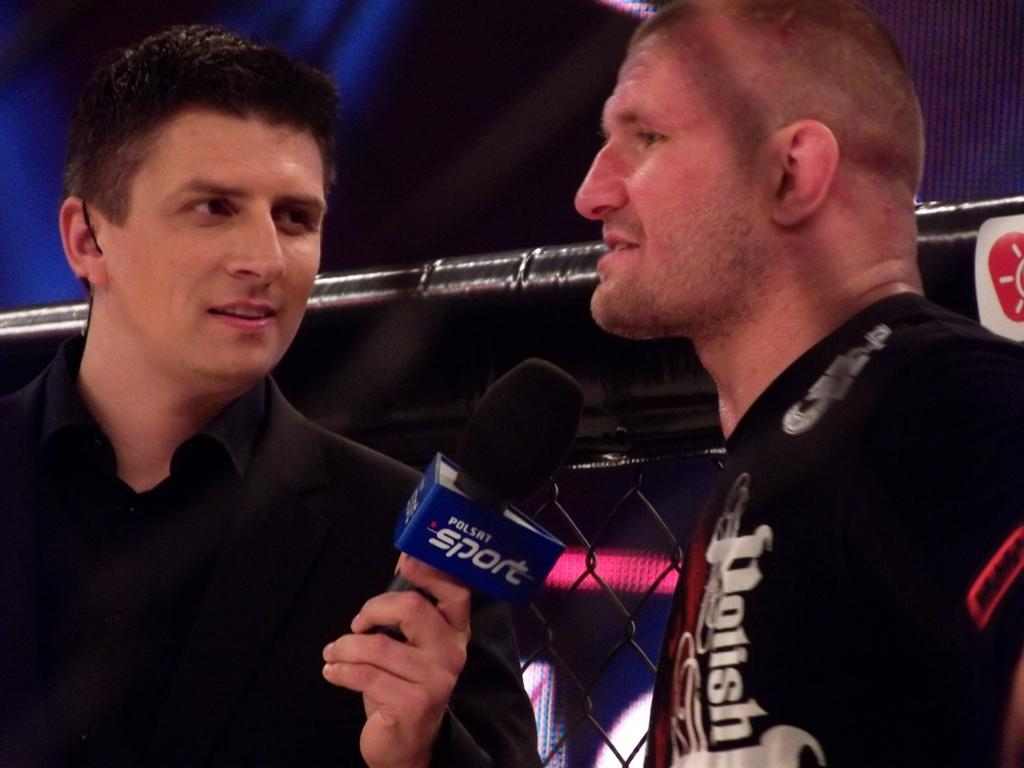How many people are in the image? There are two men in the image. What are the men doing in the image? The men are standing in the image. Can you describe what one of the men is holding? One of the men is holding a mic in his hand. What type of quince can be seen hanging from the mic in the image? There is no quince present in the image, and the mic is not attached to any fruit. 